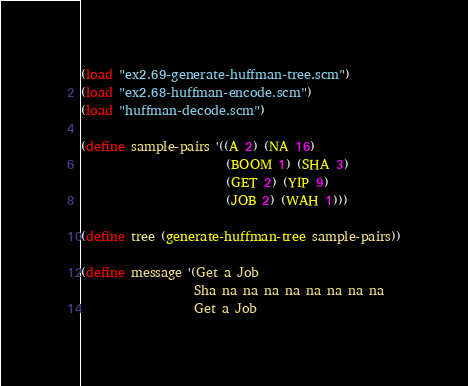<code> <loc_0><loc_0><loc_500><loc_500><_Scheme_>(load "ex2.69-generate-huffman-tree.scm")
(load "ex2.68-huffman-encode.scm")
(load "huffman-decode.scm")

(define sample-pairs '((A 2) (NA 16)
                       (BOOM 1) (SHA 3)
                       (GET 2) (YIP 9)
                       (JOB 2) (WAH 1)))

(define tree (generate-huffman-tree sample-pairs))

(define message '(Get a Job
                  Sha na na na na na na na na
                  Get a Job</code> 